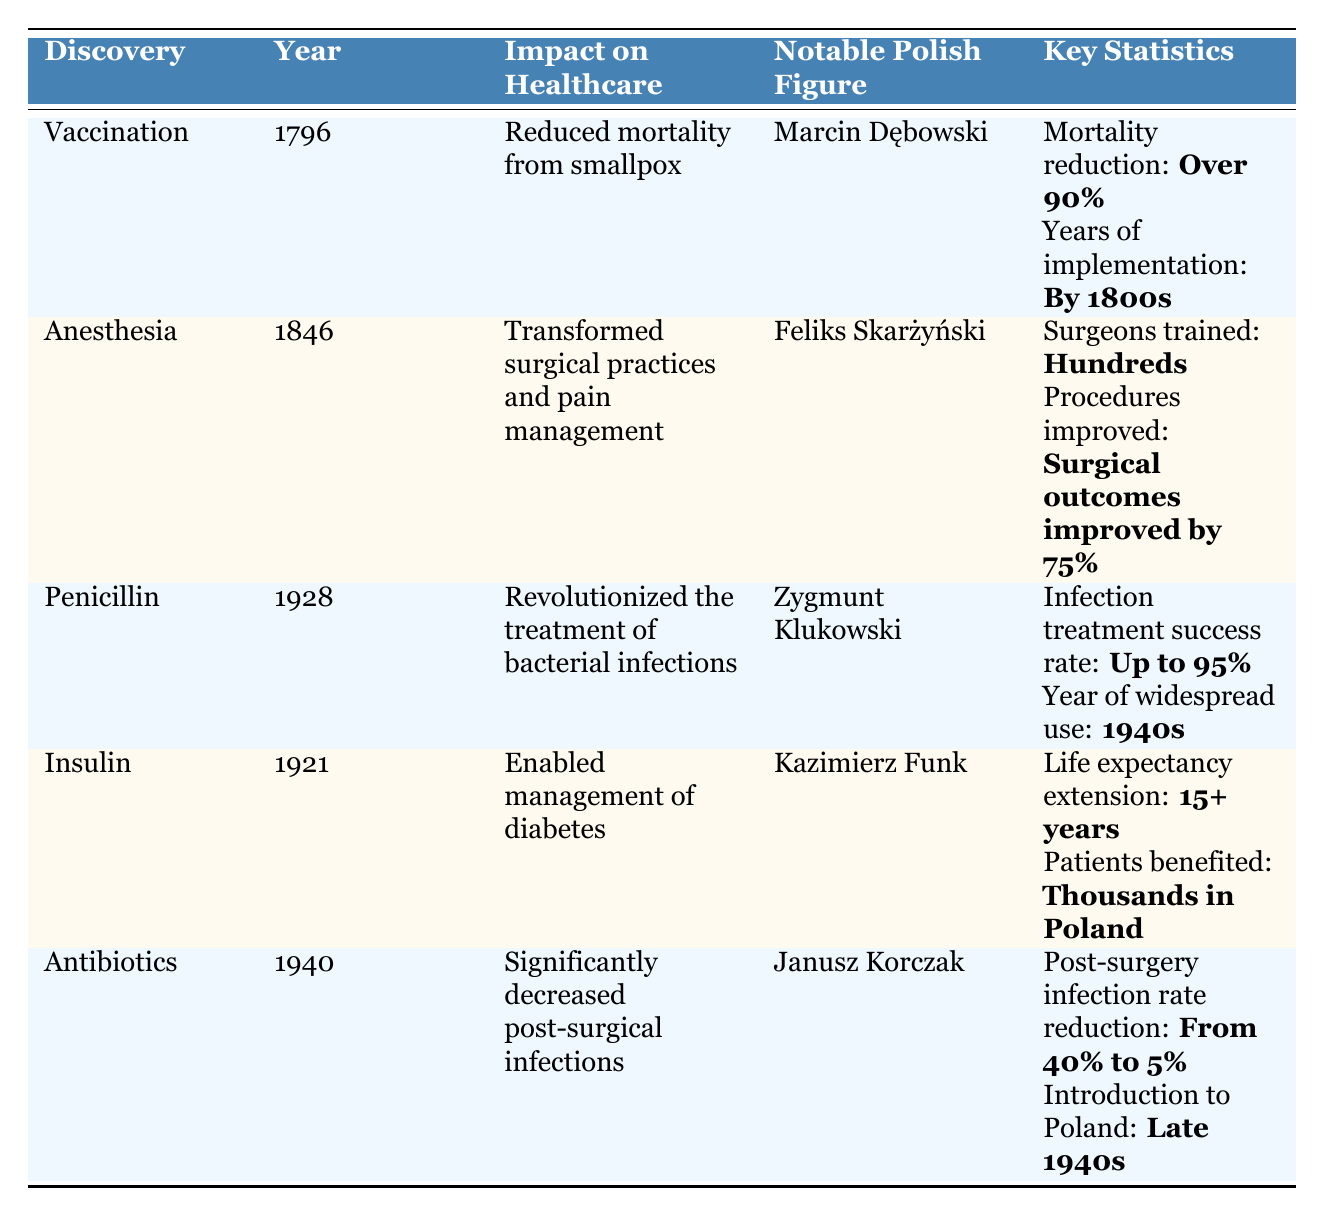What year was vaccination discovered? The table lists 'Vaccination' under the 'Discovery' column with the corresponding 'Year' being '1796'.
Answer: 1796 Who was a notable figure in the introduction of vaccination in Poland? The 'Notable Polish Figure' column associated with vaccination shows 'Marcin Dębowski' as a key contributor.
Answer: Marcin Dębowski What was the impact of anesthesia on surgical outcomes? The table states that surgical outcomes improved by 75% under the 'Key Statistics' for anesthesia.
Answer: Surgical outcomes improved by 75% How many patients benefited from insulin in Poland? The 'Patients benefited' statistic for insulin is listed as 'Thousands in Poland'.
Answer: Thousands in Poland Did antibiotics significantly decrease post-surgical infections? The table indicates a reduction in post-surgery infection rates, affirming that antibiotics did decrease such infections.
Answer: Yes In what year was penicillin widely used? The 'Year of widespread use' for penicillin is noted as the '1940s' in the 'Key Statistics' column.
Answer: 1940s What is the difference in infection rates before and after the introduction of antibiotics? Post-surgery infection rates reduced from 40% to 5%, so the difference is 40% - 5% = 35%.
Answer: 35% Which discovery allowed for the management of diabetes? The table indicates 'Insulin' as the discovery that enabled management of diabetes in the impact section.
Answer: Insulin How many surgeons were trained in the use of anesthesia? The table states under 'Key Statistics' for anesthesia that 'Hundreds' of surgeons were trained.
Answer: Hundreds Which medical discovery had the highest reported success rate for infection treatment? The success rate for penicillin is stated as 'Up to 95%', making it the highest compared to the other discoveries listed.
Answer: Up to 95% 